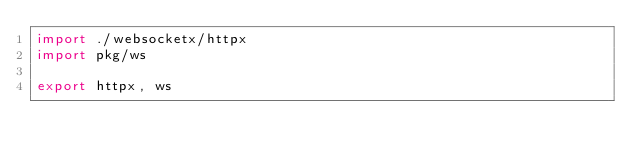<code> <loc_0><loc_0><loc_500><loc_500><_Nim_>import ./websocketx/httpx
import pkg/ws

export httpx, ws
</code> 